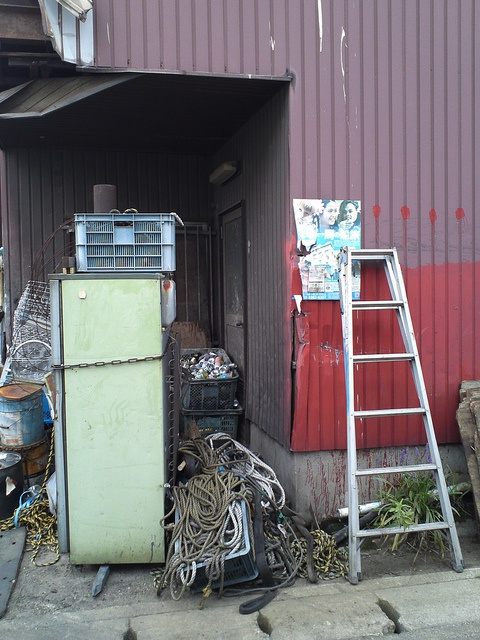Describe the objects in this image and their specific colors. I can see a refrigerator in black, beige, lightblue, and darkgray tones in this image. 